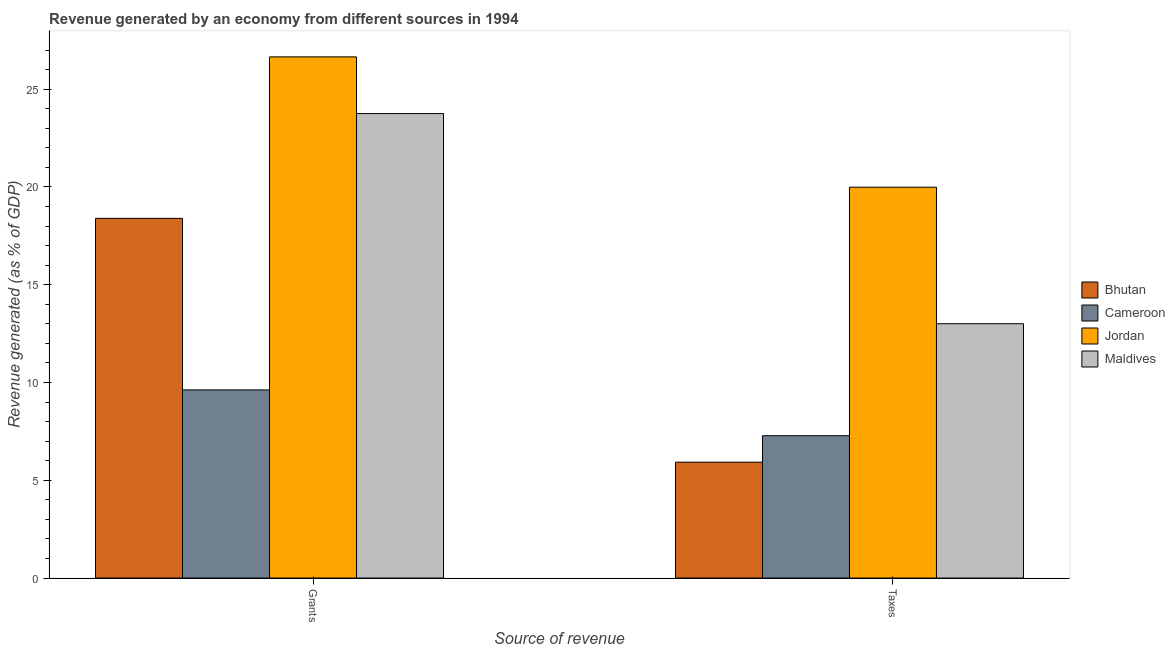How many different coloured bars are there?
Offer a terse response. 4. Are the number of bars per tick equal to the number of legend labels?
Keep it short and to the point. Yes. How many bars are there on the 1st tick from the left?
Provide a short and direct response. 4. What is the label of the 2nd group of bars from the left?
Ensure brevity in your answer.  Taxes. What is the revenue generated by grants in Maldives?
Give a very brief answer. 23.75. Across all countries, what is the maximum revenue generated by taxes?
Your response must be concise. 19.99. Across all countries, what is the minimum revenue generated by grants?
Your answer should be compact. 9.62. In which country was the revenue generated by grants maximum?
Offer a terse response. Jordan. In which country was the revenue generated by grants minimum?
Offer a terse response. Cameroon. What is the total revenue generated by grants in the graph?
Offer a terse response. 78.42. What is the difference between the revenue generated by taxes in Bhutan and that in Cameroon?
Give a very brief answer. -1.36. What is the difference between the revenue generated by grants in Jordan and the revenue generated by taxes in Cameroon?
Your answer should be compact. 19.37. What is the average revenue generated by grants per country?
Give a very brief answer. 19.6. What is the difference between the revenue generated by grants and revenue generated by taxes in Jordan?
Provide a short and direct response. 6.66. In how many countries, is the revenue generated by taxes greater than 11 %?
Your answer should be very brief. 2. What is the ratio of the revenue generated by grants in Jordan to that in Maldives?
Make the answer very short. 1.12. Is the revenue generated by taxes in Bhutan less than that in Cameroon?
Keep it short and to the point. Yes. What does the 4th bar from the left in Grants represents?
Your response must be concise. Maldives. What does the 2nd bar from the right in Taxes represents?
Offer a very short reply. Jordan. How many bars are there?
Give a very brief answer. 8. Are all the bars in the graph horizontal?
Offer a terse response. No. How many countries are there in the graph?
Make the answer very short. 4. What is the difference between two consecutive major ticks on the Y-axis?
Provide a succinct answer. 5. Are the values on the major ticks of Y-axis written in scientific E-notation?
Offer a very short reply. No. Does the graph contain any zero values?
Your response must be concise. No. Does the graph contain grids?
Keep it short and to the point. No. How many legend labels are there?
Provide a short and direct response. 4. How are the legend labels stacked?
Offer a terse response. Vertical. What is the title of the graph?
Keep it short and to the point. Revenue generated by an economy from different sources in 1994. Does "Malawi" appear as one of the legend labels in the graph?
Your response must be concise. No. What is the label or title of the X-axis?
Ensure brevity in your answer.  Source of revenue. What is the label or title of the Y-axis?
Provide a succinct answer. Revenue generated (as % of GDP). What is the Revenue generated (as % of GDP) in Bhutan in Grants?
Keep it short and to the point. 18.39. What is the Revenue generated (as % of GDP) of Cameroon in Grants?
Provide a short and direct response. 9.62. What is the Revenue generated (as % of GDP) in Jordan in Grants?
Keep it short and to the point. 26.65. What is the Revenue generated (as % of GDP) of Maldives in Grants?
Ensure brevity in your answer.  23.75. What is the Revenue generated (as % of GDP) in Bhutan in Taxes?
Keep it short and to the point. 5.92. What is the Revenue generated (as % of GDP) of Cameroon in Taxes?
Keep it short and to the point. 7.28. What is the Revenue generated (as % of GDP) in Jordan in Taxes?
Your response must be concise. 19.99. What is the Revenue generated (as % of GDP) of Maldives in Taxes?
Your answer should be compact. 13. Across all Source of revenue, what is the maximum Revenue generated (as % of GDP) in Bhutan?
Your answer should be compact. 18.39. Across all Source of revenue, what is the maximum Revenue generated (as % of GDP) of Cameroon?
Keep it short and to the point. 9.62. Across all Source of revenue, what is the maximum Revenue generated (as % of GDP) of Jordan?
Give a very brief answer. 26.65. Across all Source of revenue, what is the maximum Revenue generated (as % of GDP) in Maldives?
Your answer should be very brief. 23.75. Across all Source of revenue, what is the minimum Revenue generated (as % of GDP) of Bhutan?
Make the answer very short. 5.92. Across all Source of revenue, what is the minimum Revenue generated (as % of GDP) in Cameroon?
Ensure brevity in your answer.  7.28. Across all Source of revenue, what is the minimum Revenue generated (as % of GDP) in Jordan?
Offer a very short reply. 19.99. Across all Source of revenue, what is the minimum Revenue generated (as % of GDP) of Maldives?
Ensure brevity in your answer.  13. What is the total Revenue generated (as % of GDP) in Bhutan in the graph?
Offer a terse response. 24.32. What is the total Revenue generated (as % of GDP) of Cameroon in the graph?
Ensure brevity in your answer.  16.9. What is the total Revenue generated (as % of GDP) in Jordan in the graph?
Keep it short and to the point. 46.64. What is the total Revenue generated (as % of GDP) of Maldives in the graph?
Give a very brief answer. 36.76. What is the difference between the Revenue generated (as % of GDP) in Bhutan in Grants and that in Taxes?
Offer a terse response. 12.47. What is the difference between the Revenue generated (as % of GDP) in Cameroon in Grants and that in Taxes?
Offer a very short reply. 2.34. What is the difference between the Revenue generated (as % of GDP) of Jordan in Grants and that in Taxes?
Provide a succinct answer. 6.66. What is the difference between the Revenue generated (as % of GDP) of Maldives in Grants and that in Taxes?
Provide a succinct answer. 10.75. What is the difference between the Revenue generated (as % of GDP) in Bhutan in Grants and the Revenue generated (as % of GDP) in Cameroon in Taxes?
Your answer should be very brief. 11.11. What is the difference between the Revenue generated (as % of GDP) of Bhutan in Grants and the Revenue generated (as % of GDP) of Jordan in Taxes?
Ensure brevity in your answer.  -1.59. What is the difference between the Revenue generated (as % of GDP) in Bhutan in Grants and the Revenue generated (as % of GDP) in Maldives in Taxes?
Your response must be concise. 5.39. What is the difference between the Revenue generated (as % of GDP) in Cameroon in Grants and the Revenue generated (as % of GDP) in Jordan in Taxes?
Give a very brief answer. -10.37. What is the difference between the Revenue generated (as % of GDP) of Cameroon in Grants and the Revenue generated (as % of GDP) of Maldives in Taxes?
Keep it short and to the point. -3.38. What is the difference between the Revenue generated (as % of GDP) in Jordan in Grants and the Revenue generated (as % of GDP) in Maldives in Taxes?
Your answer should be very brief. 13.64. What is the average Revenue generated (as % of GDP) of Bhutan per Source of revenue?
Make the answer very short. 12.16. What is the average Revenue generated (as % of GDP) of Cameroon per Source of revenue?
Your response must be concise. 8.45. What is the average Revenue generated (as % of GDP) of Jordan per Source of revenue?
Keep it short and to the point. 23.32. What is the average Revenue generated (as % of GDP) in Maldives per Source of revenue?
Ensure brevity in your answer.  18.38. What is the difference between the Revenue generated (as % of GDP) of Bhutan and Revenue generated (as % of GDP) of Cameroon in Grants?
Your answer should be very brief. 8.77. What is the difference between the Revenue generated (as % of GDP) of Bhutan and Revenue generated (as % of GDP) of Jordan in Grants?
Keep it short and to the point. -8.26. What is the difference between the Revenue generated (as % of GDP) in Bhutan and Revenue generated (as % of GDP) in Maldives in Grants?
Keep it short and to the point. -5.36. What is the difference between the Revenue generated (as % of GDP) in Cameroon and Revenue generated (as % of GDP) in Jordan in Grants?
Provide a succinct answer. -17.03. What is the difference between the Revenue generated (as % of GDP) of Cameroon and Revenue generated (as % of GDP) of Maldives in Grants?
Ensure brevity in your answer.  -14.13. What is the difference between the Revenue generated (as % of GDP) in Jordan and Revenue generated (as % of GDP) in Maldives in Grants?
Your answer should be very brief. 2.9. What is the difference between the Revenue generated (as % of GDP) in Bhutan and Revenue generated (as % of GDP) in Cameroon in Taxes?
Make the answer very short. -1.36. What is the difference between the Revenue generated (as % of GDP) of Bhutan and Revenue generated (as % of GDP) of Jordan in Taxes?
Your answer should be compact. -14.06. What is the difference between the Revenue generated (as % of GDP) of Bhutan and Revenue generated (as % of GDP) of Maldives in Taxes?
Offer a very short reply. -7.08. What is the difference between the Revenue generated (as % of GDP) of Cameroon and Revenue generated (as % of GDP) of Jordan in Taxes?
Offer a terse response. -12.71. What is the difference between the Revenue generated (as % of GDP) in Cameroon and Revenue generated (as % of GDP) in Maldives in Taxes?
Offer a very short reply. -5.72. What is the difference between the Revenue generated (as % of GDP) of Jordan and Revenue generated (as % of GDP) of Maldives in Taxes?
Give a very brief answer. 6.98. What is the ratio of the Revenue generated (as % of GDP) in Bhutan in Grants to that in Taxes?
Offer a terse response. 3.1. What is the ratio of the Revenue generated (as % of GDP) in Cameroon in Grants to that in Taxes?
Ensure brevity in your answer.  1.32. What is the ratio of the Revenue generated (as % of GDP) in Jordan in Grants to that in Taxes?
Give a very brief answer. 1.33. What is the ratio of the Revenue generated (as % of GDP) in Maldives in Grants to that in Taxes?
Offer a terse response. 1.83. What is the difference between the highest and the second highest Revenue generated (as % of GDP) of Bhutan?
Your answer should be compact. 12.47. What is the difference between the highest and the second highest Revenue generated (as % of GDP) in Cameroon?
Your answer should be very brief. 2.34. What is the difference between the highest and the second highest Revenue generated (as % of GDP) of Jordan?
Provide a short and direct response. 6.66. What is the difference between the highest and the second highest Revenue generated (as % of GDP) in Maldives?
Provide a succinct answer. 10.75. What is the difference between the highest and the lowest Revenue generated (as % of GDP) in Bhutan?
Keep it short and to the point. 12.47. What is the difference between the highest and the lowest Revenue generated (as % of GDP) in Cameroon?
Your response must be concise. 2.34. What is the difference between the highest and the lowest Revenue generated (as % of GDP) in Jordan?
Ensure brevity in your answer.  6.66. What is the difference between the highest and the lowest Revenue generated (as % of GDP) in Maldives?
Your answer should be very brief. 10.75. 